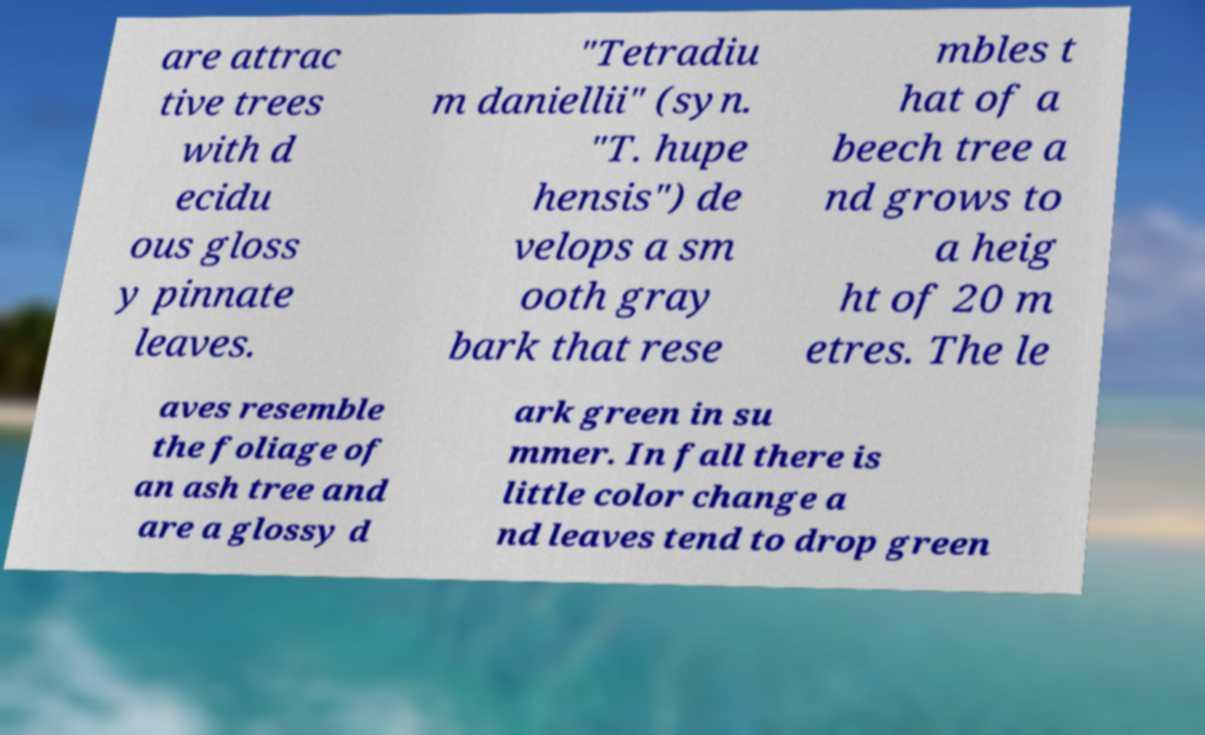Can you accurately transcribe the text from the provided image for me? are attrac tive trees with d ecidu ous gloss y pinnate leaves. "Tetradiu m daniellii" (syn. "T. hupe hensis") de velops a sm ooth gray bark that rese mbles t hat of a beech tree a nd grows to a heig ht of 20 m etres. The le aves resemble the foliage of an ash tree and are a glossy d ark green in su mmer. In fall there is little color change a nd leaves tend to drop green 